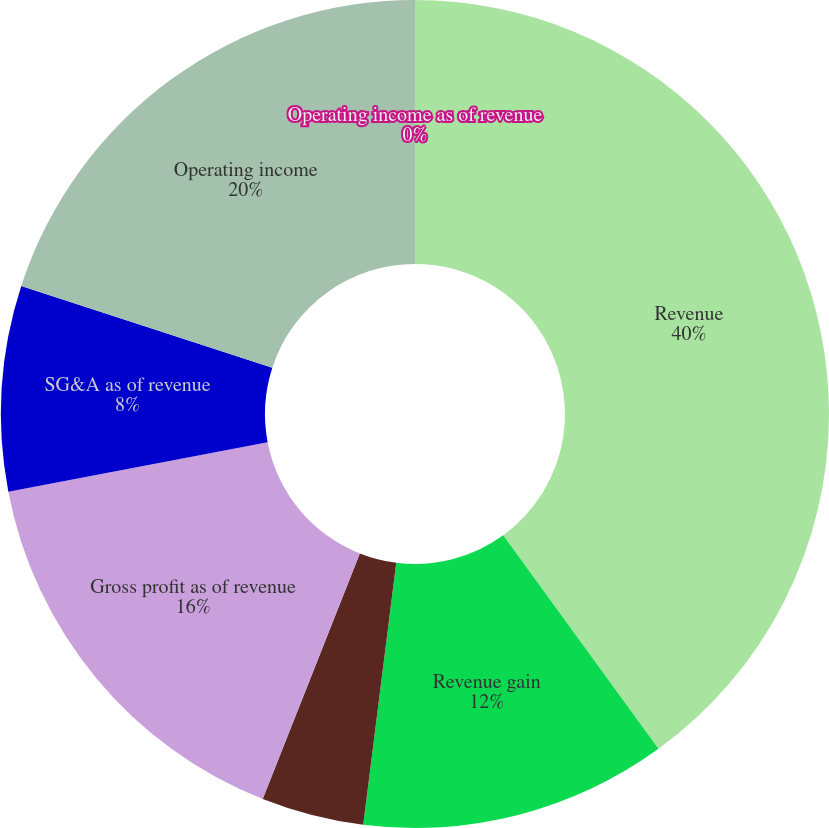<chart> <loc_0><loc_0><loc_500><loc_500><pie_chart><fcel>Revenue<fcel>Revenue gain<fcel>Comparable store sales<fcel>Gross profit as of revenue<fcel>SG&A as of revenue<fcel>Operating income<fcel>Operating income as of revenue<nl><fcel>39.99%<fcel>12.0%<fcel>4.0%<fcel>16.0%<fcel>8.0%<fcel>20.0%<fcel>0.0%<nl></chart> 